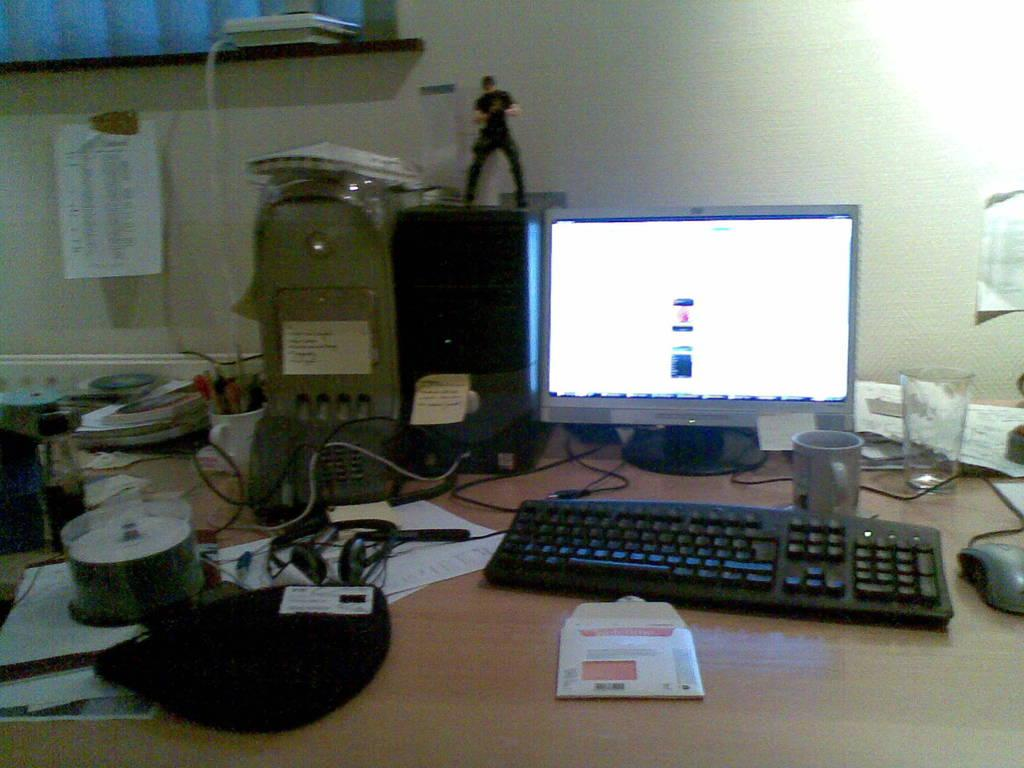What is the main object in the middle of the image? There is a table in the middle of the image. What electronic devices are on the table? A monitor, keyboard, mouse, CPU, and headset are on the table. What type of beverage containers are on the table? A cup and a glass are on the table. What type of storage media is on the table? CDs are on the table. What is visible in the background of the image? There is a window and a wall in the background. Is there any communication device in the background? Yes, there is a telephone in the background. Where is the sister of the person in the image? There is no person or sister mentioned in the image, so we cannot determine their location. Does the existence of the table in the image prove the existence of a roof? The presence of a table in the image does not necessarily prove the existence of a roof, as the table could be located in an open area or under a different type of structure. 